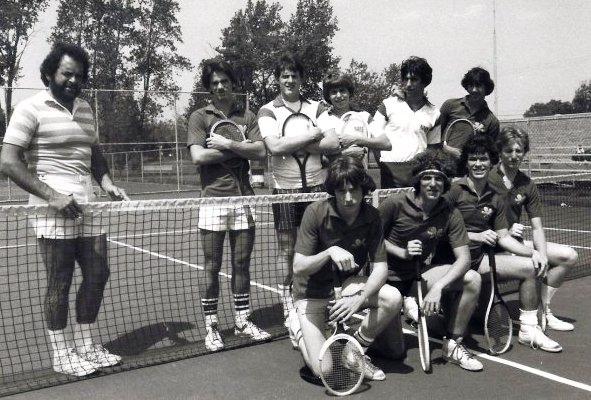How many people?
Concise answer only. 10. Is the photo black and white?
Quick response, please. Yes. What race is the man on the left?
Answer briefly. White. 